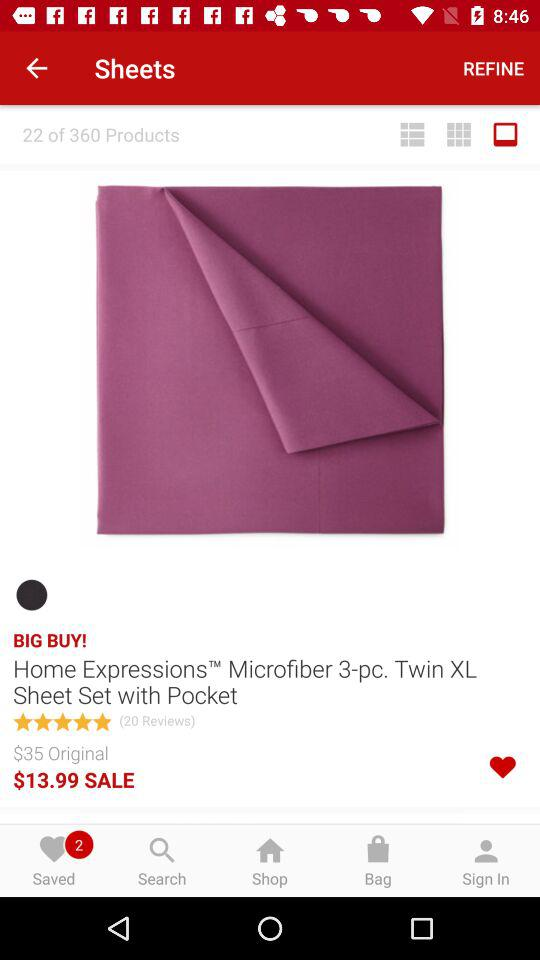What is the original price of "Twin XL Sheet Set with Pocket"? The original price is $35. 